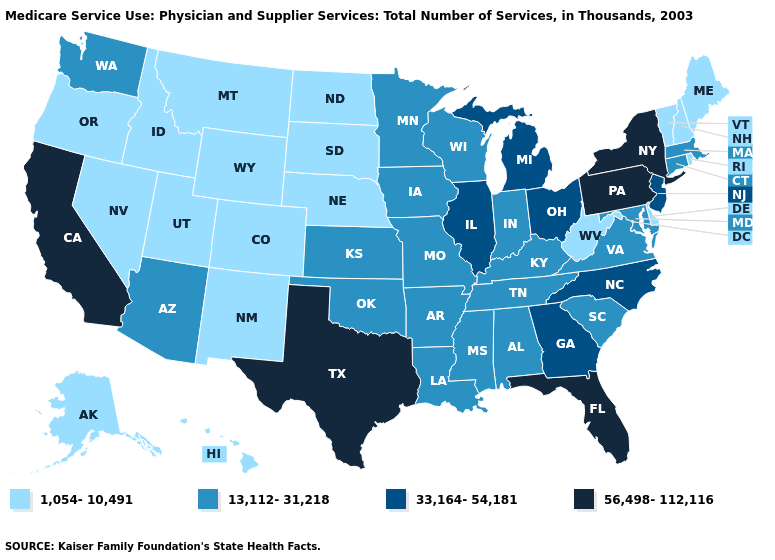Does Massachusetts have a lower value than Florida?
Be succinct. Yes. Does Oklahoma have a higher value than Pennsylvania?
Answer briefly. No. What is the value of Arizona?
Concise answer only. 13,112-31,218. Name the states that have a value in the range 56,498-112,116?
Answer briefly. California, Florida, New York, Pennsylvania, Texas. Does Oklahoma have the highest value in the South?
Keep it brief. No. How many symbols are there in the legend?
Keep it brief. 4. What is the value of Vermont?
Give a very brief answer. 1,054-10,491. Name the states that have a value in the range 13,112-31,218?
Give a very brief answer. Alabama, Arizona, Arkansas, Connecticut, Indiana, Iowa, Kansas, Kentucky, Louisiana, Maryland, Massachusetts, Minnesota, Mississippi, Missouri, Oklahoma, South Carolina, Tennessee, Virginia, Washington, Wisconsin. Name the states that have a value in the range 1,054-10,491?
Keep it brief. Alaska, Colorado, Delaware, Hawaii, Idaho, Maine, Montana, Nebraska, Nevada, New Hampshire, New Mexico, North Dakota, Oregon, Rhode Island, South Dakota, Utah, Vermont, West Virginia, Wyoming. Does North Dakota have the same value as Alaska?
Give a very brief answer. Yes. Does Hawaii have the highest value in the West?
Be succinct. No. Does California have the highest value in the West?
Quick response, please. Yes. Name the states that have a value in the range 1,054-10,491?
Concise answer only. Alaska, Colorado, Delaware, Hawaii, Idaho, Maine, Montana, Nebraska, Nevada, New Hampshire, New Mexico, North Dakota, Oregon, Rhode Island, South Dakota, Utah, Vermont, West Virginia, Wyoming. Does the first symbol in the legend represent the smallest category?
Write a very short answer. Yes. 